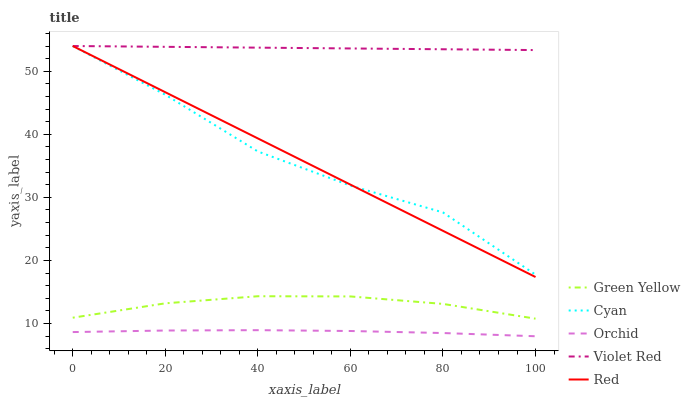Does Orchid have the minimum area under the curve?
Answer yes or no. Yes. Does Violet Red have the maximum area under the curve?
Answer yes or no. Yes. Does Green Yellow have the minimum area under the curve?
Answer yes or no. No. Does Green Yellow have the maximum area under the curve?
Answer yes or no. No. Is Red the smoothest?
Answer yes or no. Yes. Is Cyan the roughest?
Answer yes or no. Yes. Is Violet Red the smoothest?
Answer yes or no. No. Is Violet Red the roughest?
Answer yes or no. No. Does Orchid have the lowest value?
Answer yes or no. Yes. Does Green Yellow have the lowest value?
Answer yes or no. No. Does Red have the highest value?
Answer yes or no. Yes. Does Green Yellow have the highest value?
Answer yes or no. No. Is Green Yellow less than Violet Red?
Answer yes or no. Yes. Is Green Yellow greater than Orchid?
Answer yes or no. Yes. Does Cyan intersect Violet Red?
Answer yes or no. Yes. Is Cyan less than Violet Red?
Answer yes or no. No. Is Cyan greater than Violet Red?
Answer yes or no. No. Does Green Yellow intersect Violet Red?
Answer yes or no. No. 